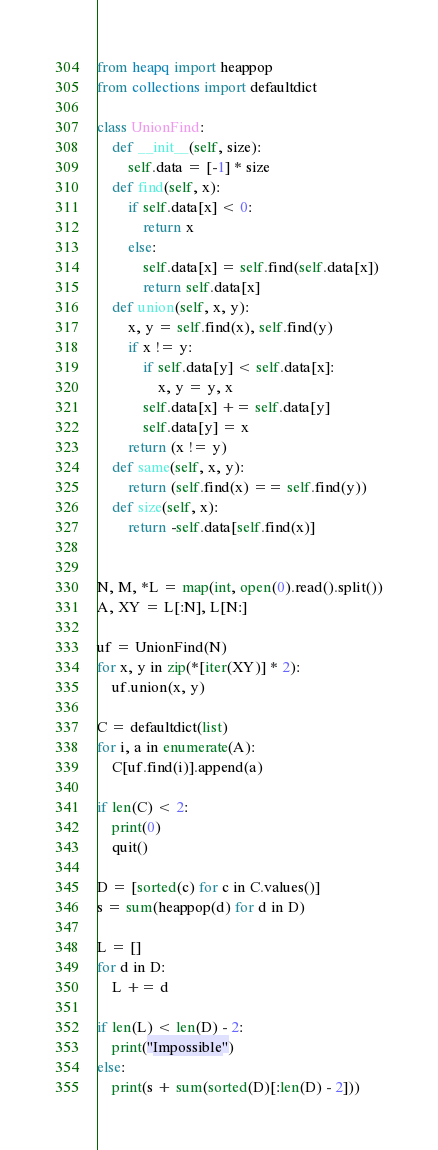<code> <loc_0><loc_0><loc_500><loc_500><_Python_>from heapq import heappop
from collections import defaultdict

class UnionFind:
    def __init__(self, size):
        self.data = [-1] * size
    def find(self, x):
        if self.data[x] < 0:
            return x
        else:
            self.data[x] = self.find(self.data[x])
            return self.data[x]
    def union(self, x, y):
        x, y = self.find(x), self.find(y)
        if x != y:
            if self.data[y] < self.data[x]:
                x, y = y, x
            self.data[x] += self.data[y]
            self.data[y] = x
        return (x != y)
    def same(self, x, y):
        return (self.find(x) == self.find(y))
    def size(self, x):
        return -self.data[self.find(x)]


N, M, *L = map(int, open(0).read().split())
A, XY = L[:N], L[N:]

uf = UnionFind(N)
for x, y in zip(*[iter(XY)] * 2):
    uf.union(x, y)

C = defaultdict(list)
for i, a in enumerate(A):
    C[uf.find(i)].append(a)

if len(C) < 2:
    print(0)
    quit()

D = [sorted(c) for c in C.values()]
s = sum(heappop(d) for d in D)

L = []
for d in D:
    L += d

if len(L) < len(D) - 2:
    print("Impossible")
else:
    print(s + sum(sorted(D)[:len(D) - 2]))
</code> 